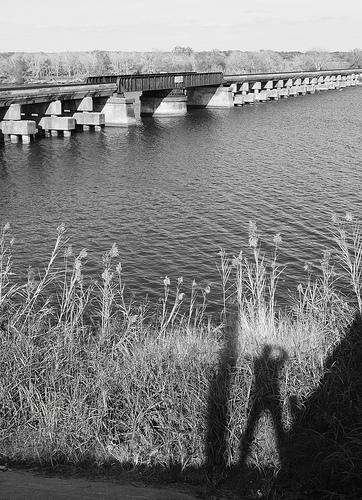Question: how many airplanes soaring?
Choices:
A. 0.
B. 2.
C. 3.
D. 4.
Answer with the letter. Answer: A Question: what has grown from the ground?
Choices:
A. Grass and weeds.
B. Trees.
C. Shrubbery.
D. Vegetables.
Answer with the letter. Answer: A Question: what pattern is across the water?
Choices:
A. Still.
B. Choppy.
C. Frothy.
D. Wavy.
Answer with the letter. Answer: D Question: how many bodies of water are there?
Choices:
A. 2.
B. 1.
C. 3.
D. 4.
Answer with the letter. Answer: B 